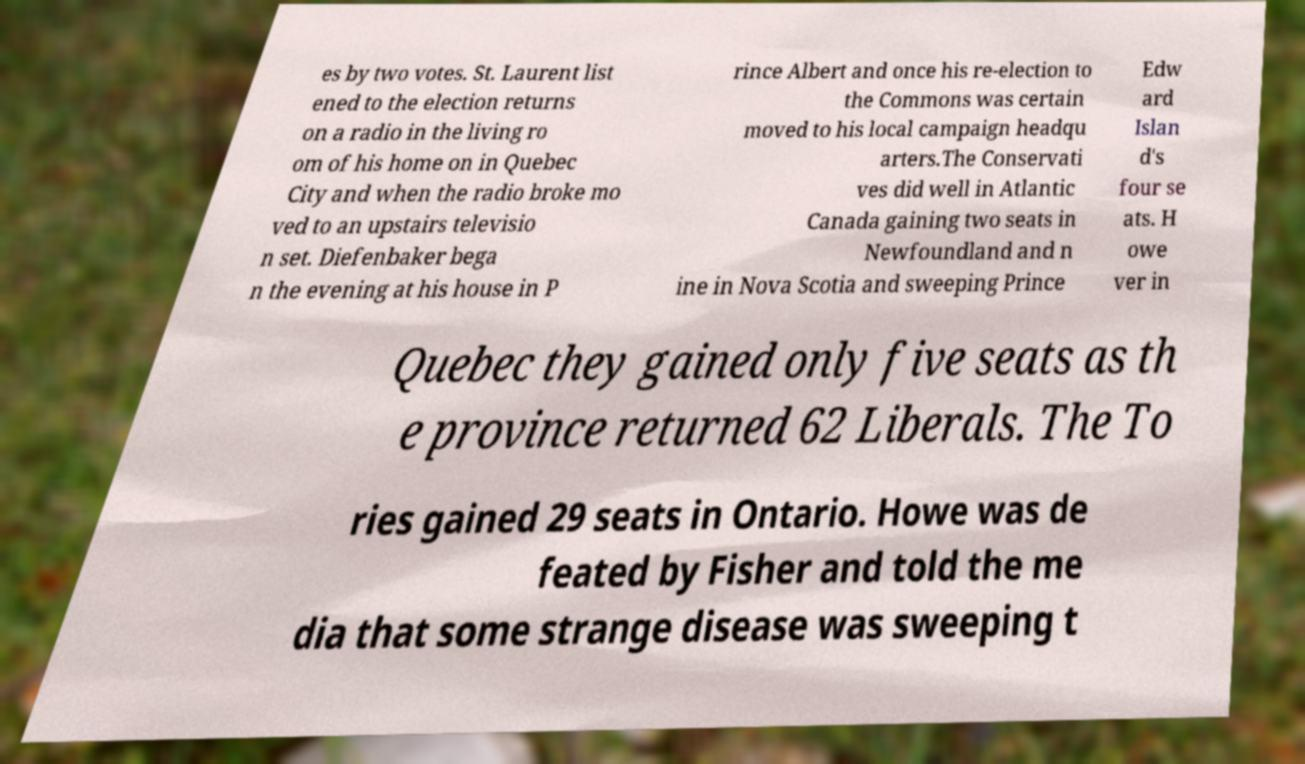What messages or text are displayed in this image? I need them in a readable, typed format. es by two votes. St. Laurent list ened to the election returns on a radio in the living ro om of his home on in Quebec City and when the radio broke mo ved to an upstairs televisio n set. Diefenbaker bega n the evening at his house in P rince Albert and once his re-election to the Commons was certain moved to his local campaign headqu arters.The Conservati ves did well in Atlantic Canada gaining two seats in Newfoundland and n ine in Nova Scotia and sweeping Prince Edw ard Islan d's four se ats. H owe ver in Quebec they gained only five seats as th e province returned 62 Liberals. The To ries gained 29 seats in Ontario. Howe was de feated by Fisher and told the me dia that some strange disease was sweeping t 